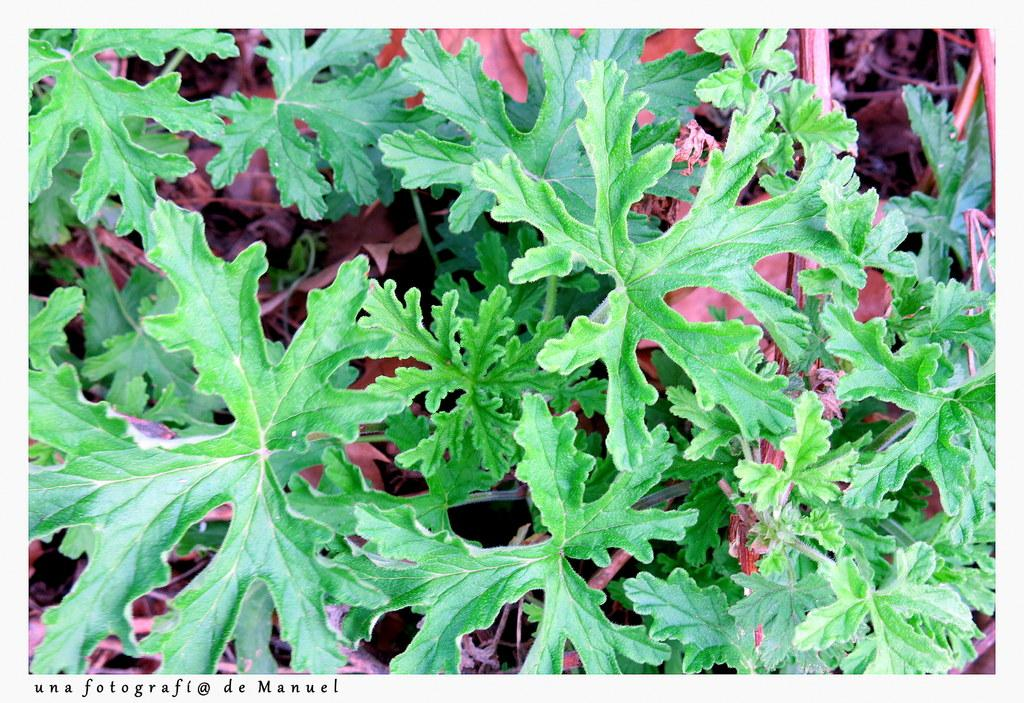What type of plants can be seen in the image? There are green color plants in the image. What is the color of the leaves under the plants? The leaves under the plants are pink in color. Is there any additional element on the image? Yes, there is a black color watermark on the left side of the image. Can you tell me how many people are standing next to the bread in the image? There is no bread or person present in the image. 